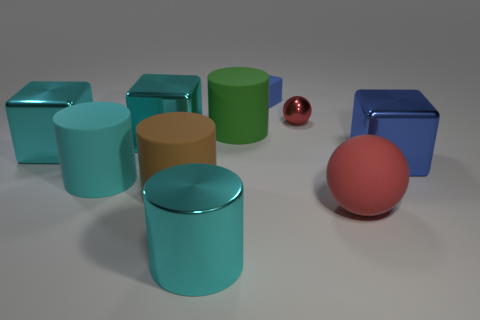What shapes are visible in the image, and do they have any distinguishable features? The image contains cylindrical shapes with a reflective surface and two spheres, a small red one and a larger peach-colored one, which have a matte finish. 